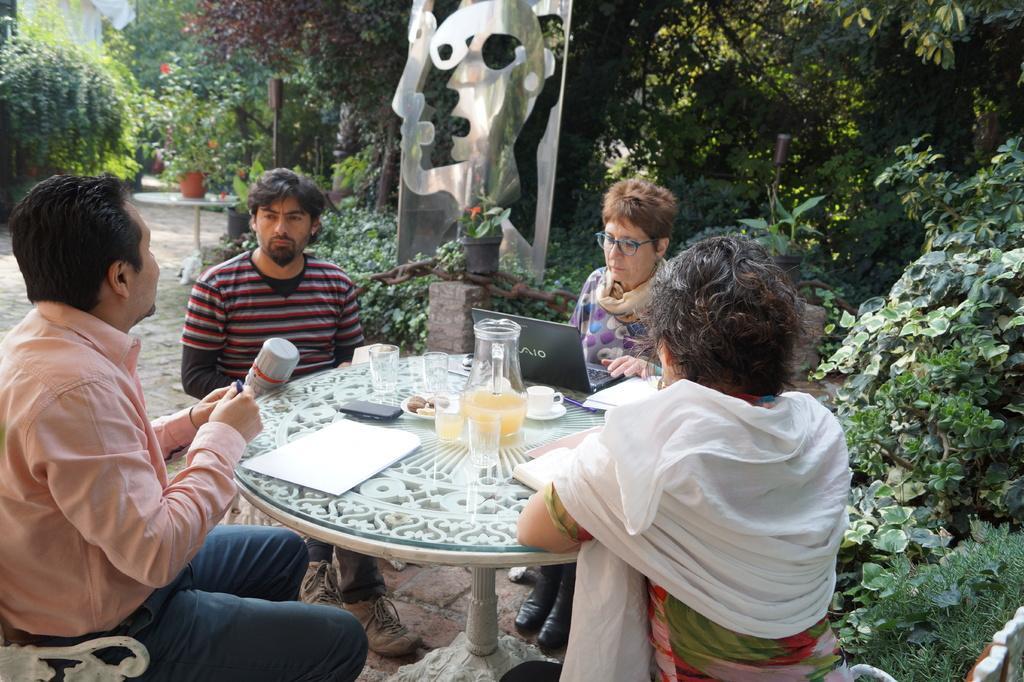Could you give a brief overview of what you see in this image? It is a open space , there are four people sitting around the table there is a jar, glass and cups and some papers on the table behind these people there is a board in the background there are lot of trees. 